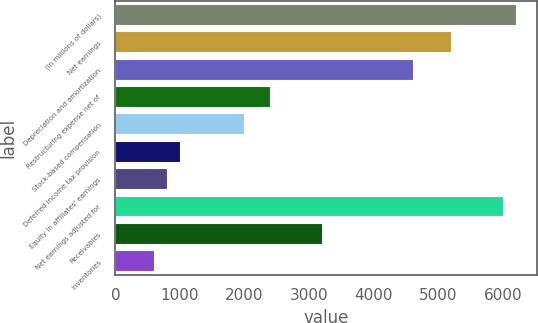Convert chart. <chart><loc_0><loc_0><loc_500><loc_500><bar_chart><fcel>(in millions of dollars)<fcel>Net earnings<fcel>Depreciation and amortization<fcel>Restructuring expense net of<fcel>Stock-based compensation<fcel>Deferred income tax provision<fcel>Equity in affiliates' earnings<fcel>Net earnings adjusted for<fcel>Receivables<fcel>Inventories<nl><fcel>6223.71<fcel>5221.16<fcel>4619.63<fcel>2414.02<fcel>2013<fcel>1010.45<fcel>809.94<fcel>6023.2<fcel>3216.06<fcel>609.43<nl></chart> 